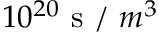Convert formula to latex. <formula><loc_0><loc_0><loc_500><loc_500>1 0 ^ { 2 0 } s / m ^ { 3 }</formula> 